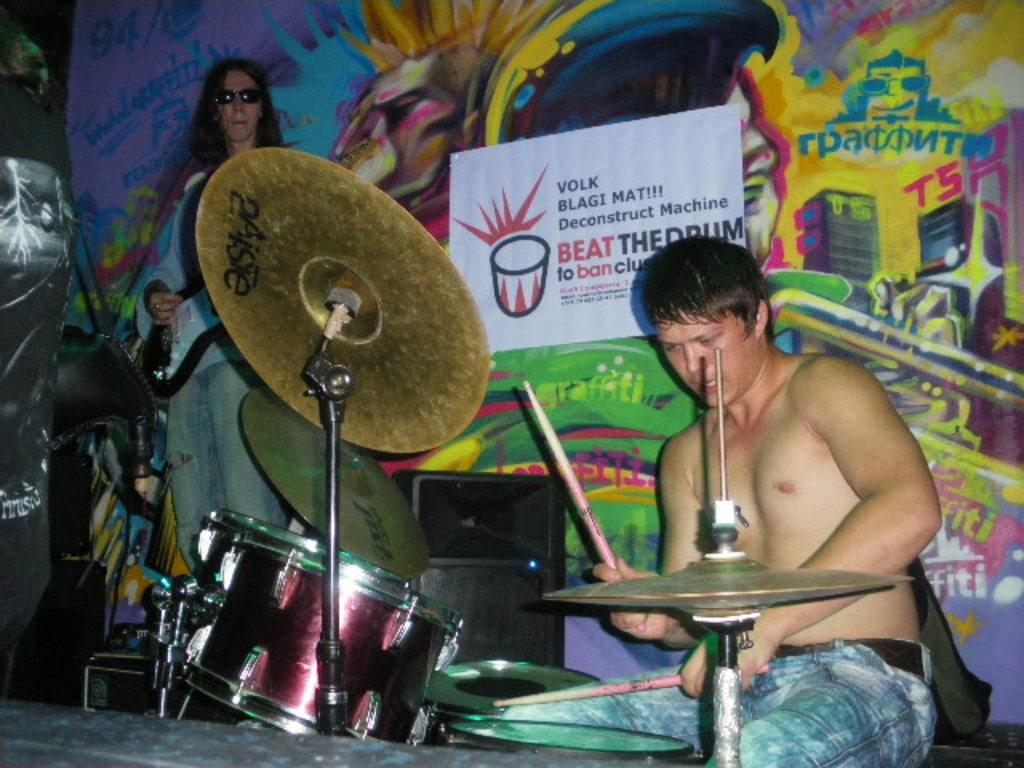What is the man in the image doing while sitting on a chair? The man is playing drums. Can you describe the other person in the image? There is a man standing on the left side of the image, and he is playing a guitar. What can be seen behind the two musicians? There is a colorful poster behind the two musicians. What type of servant can be seen attending to the musicians in the image? There is no servant present in the image; it features two musicians playing drums and guitar. What event is taking place in the image? The image does not depict a specific event; it simply shows two musicians playing their instruments. 